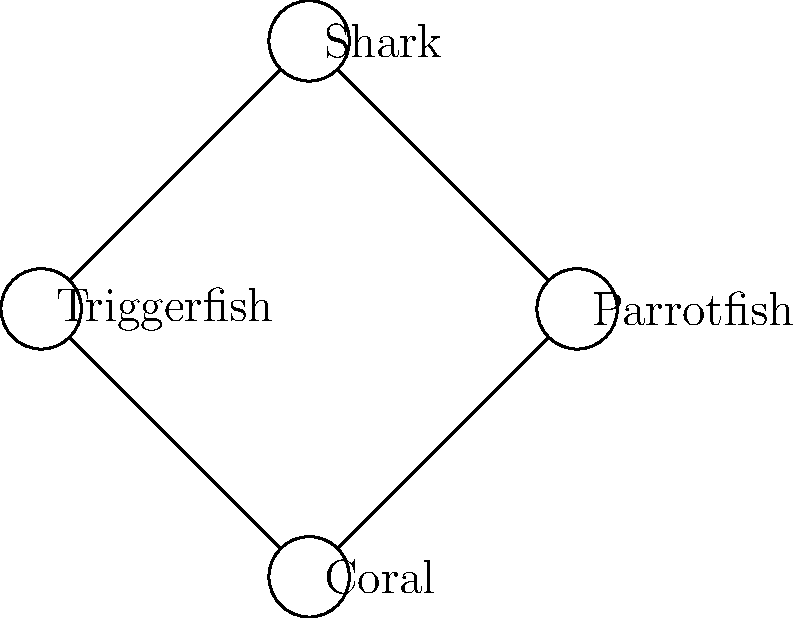Based on the ecosystem diagram of a typical coral reef in the Maldives, which species plays a crucial role in maintaining the health of the coral by preventing algal overgrowth? To answer this question, let's analyze the ecosystem diagram step-by-step:

1. The diagram shows a simple food web in a coral reef ecosystem, typical of the Maldives in the Indian Ocean.

2. We see four main components: Coral, Parrotfish, Triggerfish, and Shark.

3. The arrows indicate the direction of energy flow or feeding relationships.

4. Coral is at the base of the diagram, suggesting it's a foundation species in this ecosystem.

5. Both Parrotfish and Triggerfish have arrows pointing from the Coral to them, indicating they feed on or around the coral.

6. Parrotfish are known for their unique feeding behavior:
   a. They scrape algae off coral with their beak-like teeth.
   b. This behavior prevents algae from overgrowing and smothering the coral.
   c. Parrotfish also consume some of the coral skeleton, which they excrete as sand, contributing to beach formation.

7. Triggerfish, while they may feed around coral, do not have the same direct impact on algal control.

8. The Shark, at the top of the food web, helps maintain balance by controlling the populations of Parrotfish and Triggerfish.

Given this analysis, the Parrotfish plays a crucial role in maintaining coral health by preventing algal overgrowth through its feeding behavior.
Answer: Parrotfish 